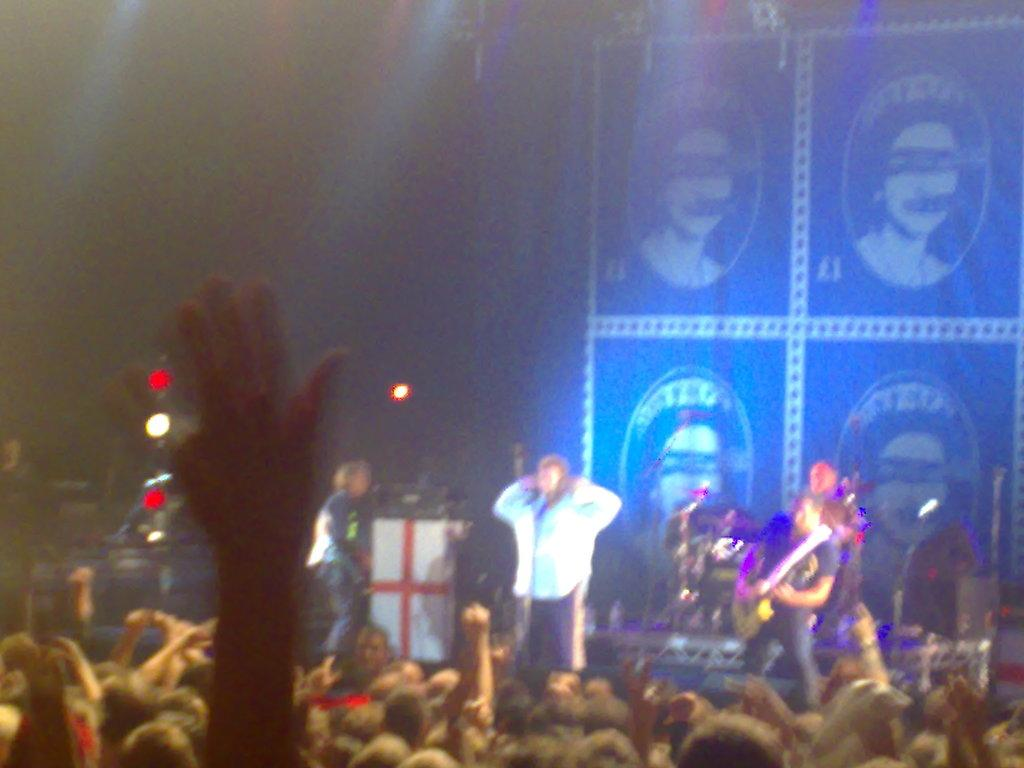What are the people on the stage doing? The people on the stage are standing. What instrument is the man holding? The man is holding a guitar. How many people are visible in the image? There is a group of people visible in the image. What can be seen on the backside of the stage? There is a banner visible on the backside. What grade of stone is used to build the stage in the image? There is no information about the grade of stone used to build the stage in the image. How are the people on the stage sorting themselves? There is no indication in the image that the people on the stage are sorting themselves. 